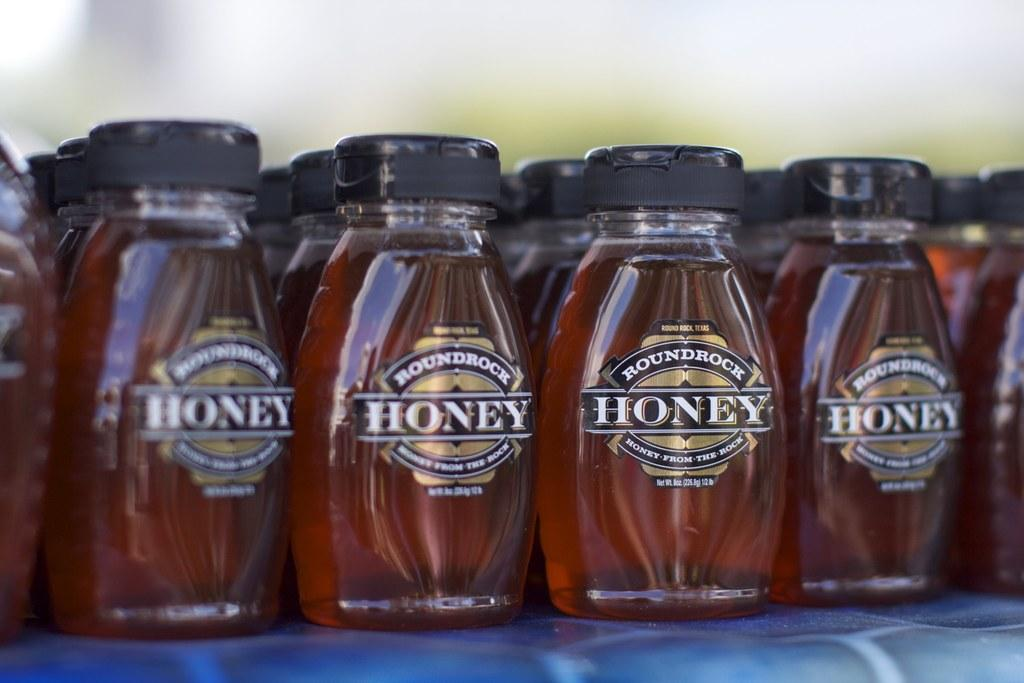Provide a one-sentence caption for the provided image. Honey bottles are lined and displayed on a shelf. 